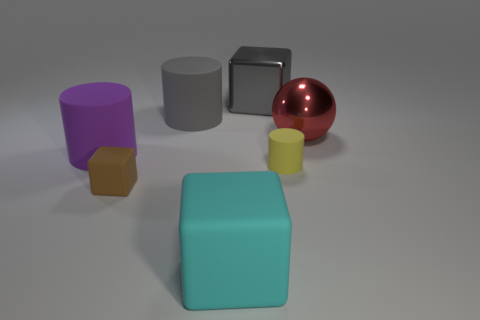Subtract all large gray cubes. How many cubes are left? 2 Add 1 purple cylinders. How many objects exist? 8 Subtract all yellow cylinders. How many cylinders are left? 2 Subtract 1 cylinders. How many cylinders are left? 2 Subtract all red cylinders. How many blue cubes are left? 0 Subtract 0 yellow balls. How many objects are left? 7 Subtract all spheres. How many objects are left? 6 Subtract all purple blocks. Subtract all yellow balls. How many blocks are left? 3 Subtract all big red shiny blocks. Subtract all tiny yellow rubber objects. How many objects are left? 6 Add 5 large metal things. How many large metal things are left? 7 